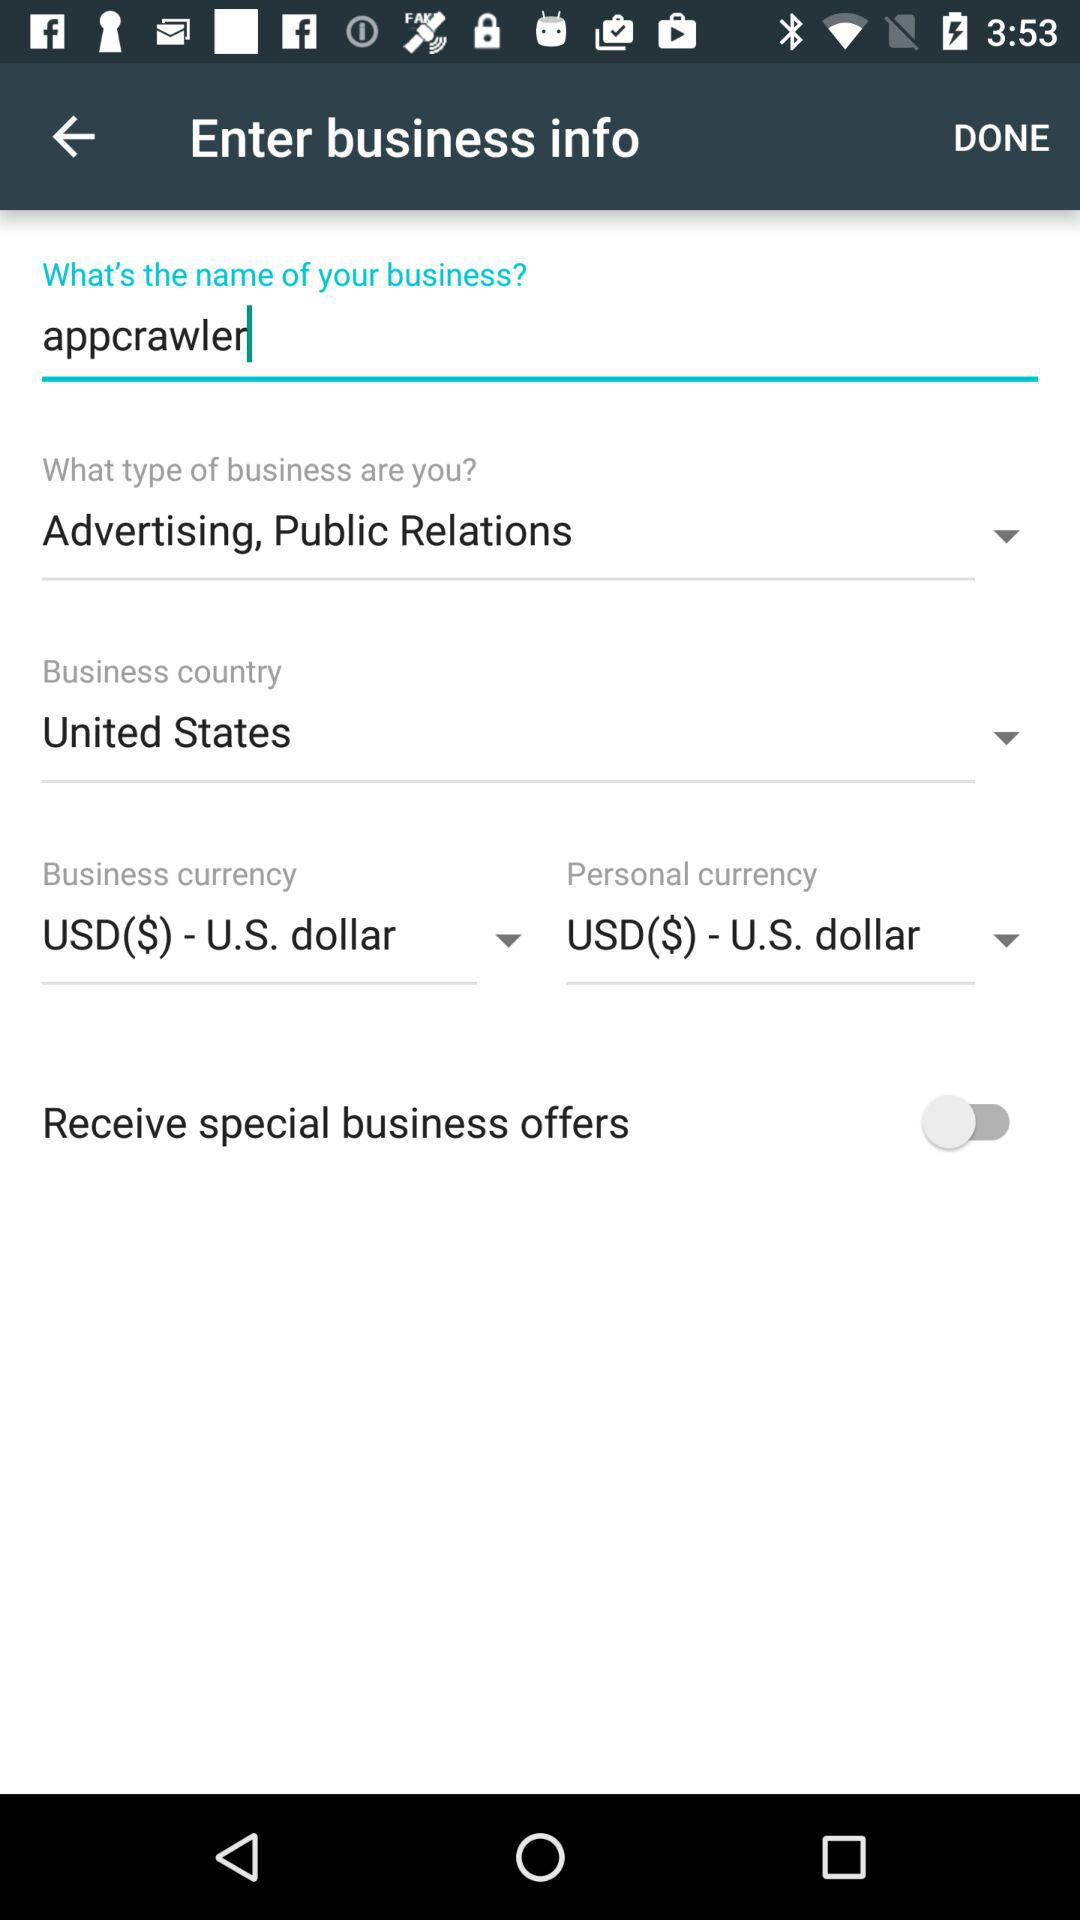What is the selected country? The selected country is the United States. 